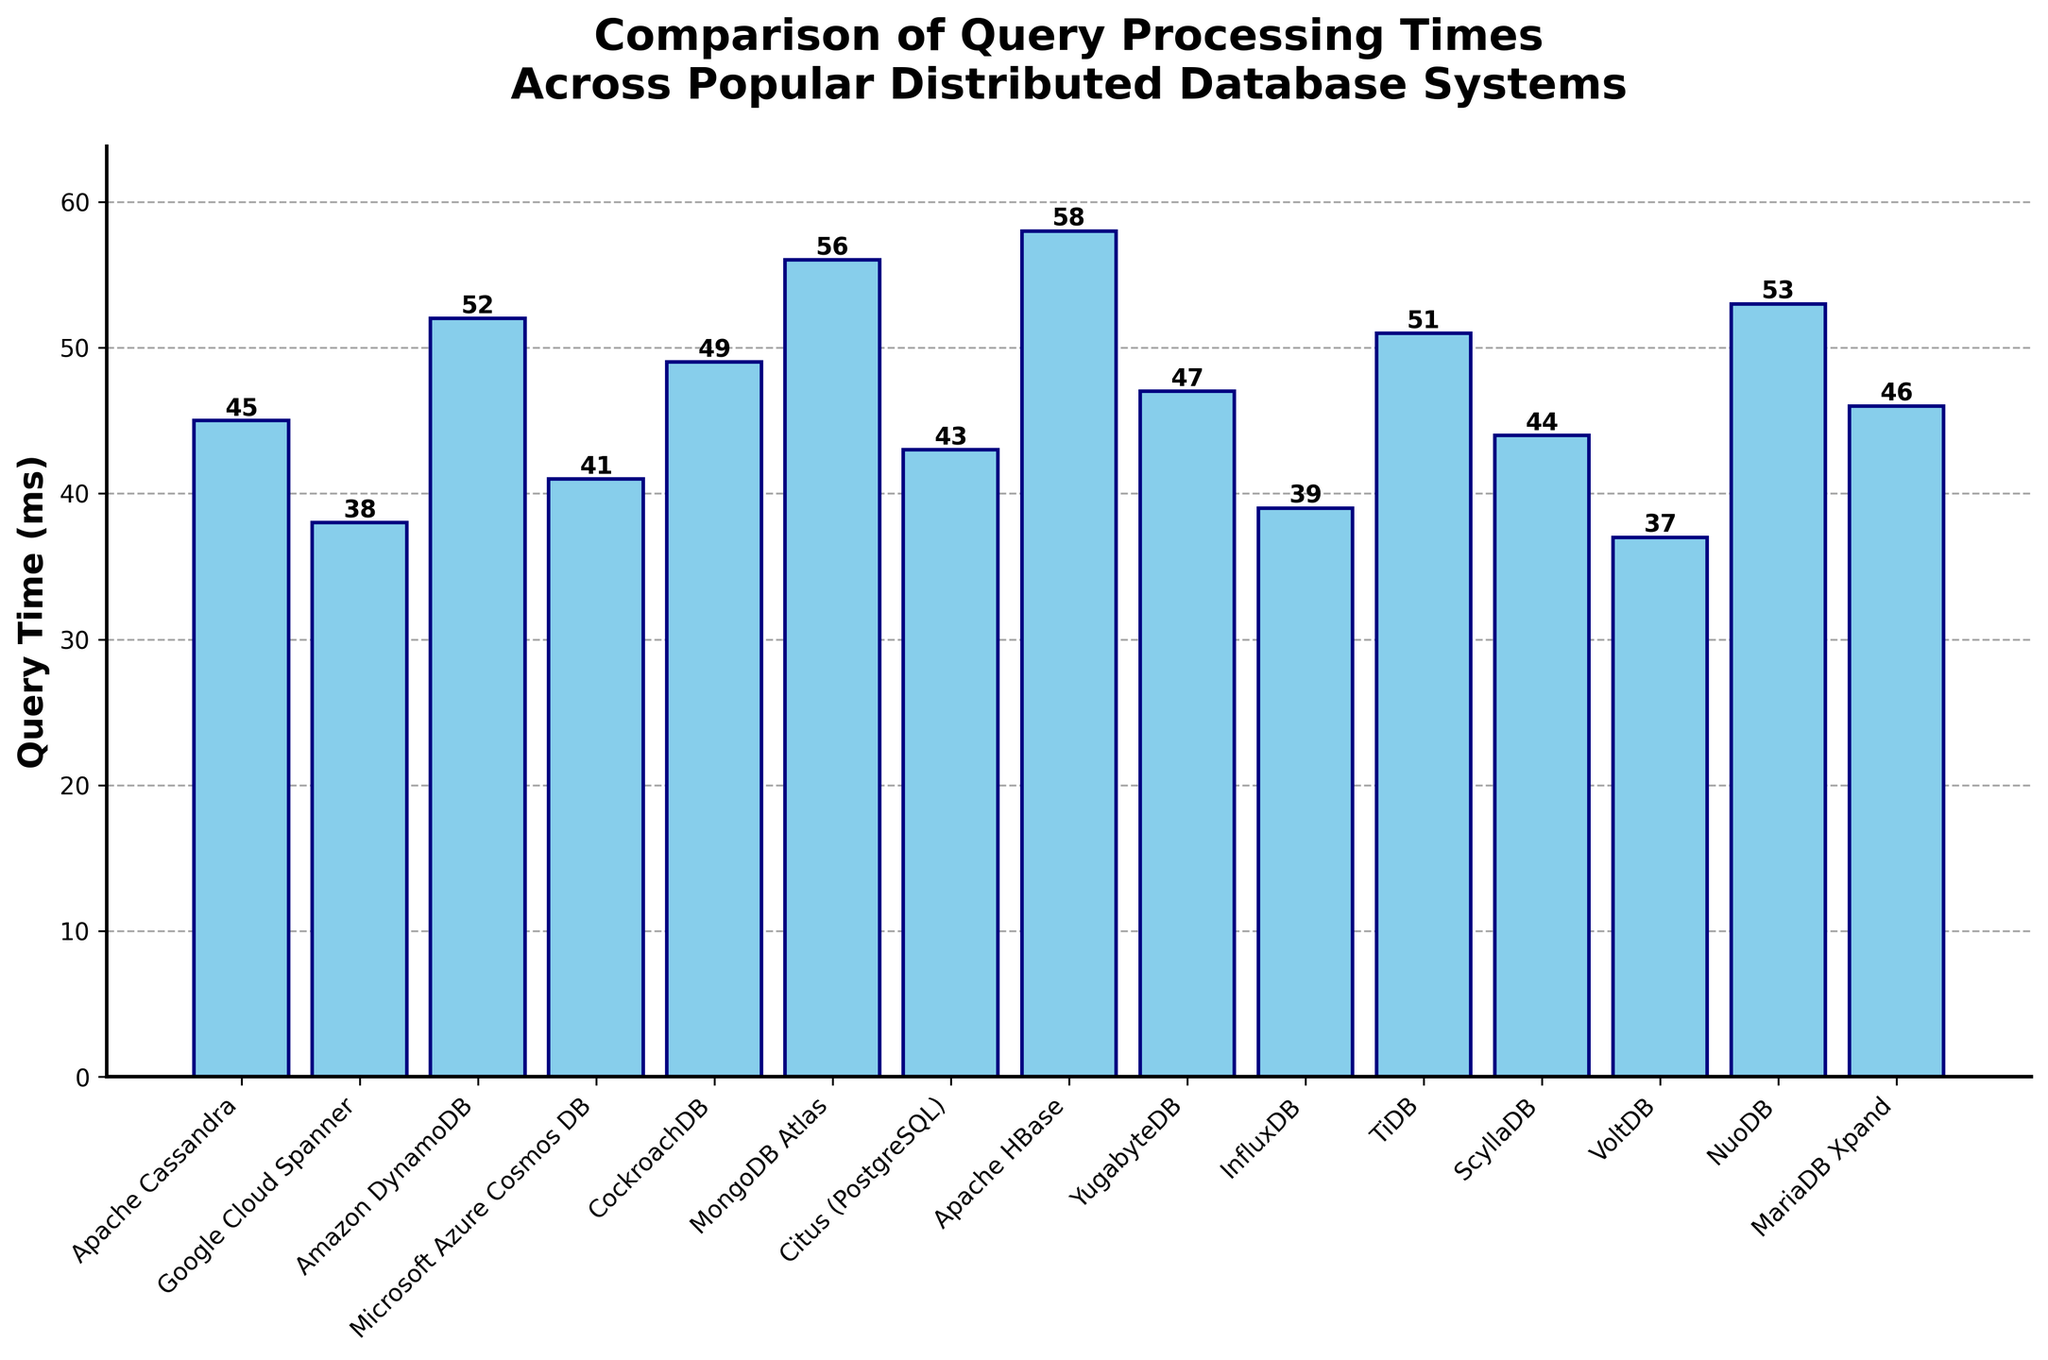Which database system has the longest query processing time? To determine this, look for the bar with the highest value on the y-axis. The tallest bar represents the system with the longest query processing time.
Answer: Apache HBase Which database system has the shortest query processing time? Examine the bar chart to find the bar with the lowest height on the y-axis. This bar indicates the system with the shortest query processing time.
Answer: VoltDB How much longer is the query processing time for MongoDB Atlas compared to VoltDB? MongoDB Atlas has a query time of 56 ms and VoltDB has a query time of 37 ms. Subtract the smaller value (VoltDB) from the larger value (MongoDB Atlas): 56 - 37 = 19 ms.
Answer: 19 ms What is the average query processing time across all database systems? Add all the query times given and then divide by the number of database systems. (45 + 38 + 52 + 41 + 49 + 56 + 43 + 58 + 47 + 39 + 51 + 44 + 37 + 53 + 46) / 15 = 44.5 ms
Answer: 44.5 ms Which database systems have a query processing time less than 40 ms? Identify all bars with values less than 40 on the y-axis. The systems with bars shorter than this threshold are being queried.
Answer: Google Cloud Spanner, InfluxDB, VoltDB What is the total query processing time for Apache Cassandra, ScyllaDB, and CockroachDB combined? Sum the query times for Apache Cassandra (45 ms), ScyllaDB (44 ms), and CockroachDB (49 ms): 45 + 44 + 49 = 138 ms
Answer: 138 ms Compare the query processing times of Microsoft Azure Cosmos DB and Amazon DynamoDB. Which one is faster and by how much? Microsoft Azure Cosmos DB has a query time of 41 ms, and Amazon DynamoDB has a query time of 52 ms. Subtract the smaller value (Microsoft Azure Cosmos DB) from the larger value (Amazon DynamoDB): 52 - 41 = 11 ms.
Answer: Microsoft Azure Cosmos DB by 11 ms How many database systems have a query processing time greater than the average of 44.5 ms? First, find the average as calculated earlier (44.5 ms). Then count the bars with heights above this value. There are 8 such database systems.
Answer: 8 systems Between Apache HBase and NuoDB, which system has a shorter query processing time and by how much? Apache HBase has a query time of 58 ms and NuoDB has a query time of 53 ms. Subtract the smaller value (NuoDB) from the larger value (Apache HBase): 58 - 53 = 5 ms.
Answer: NuoDB by 5 ms 